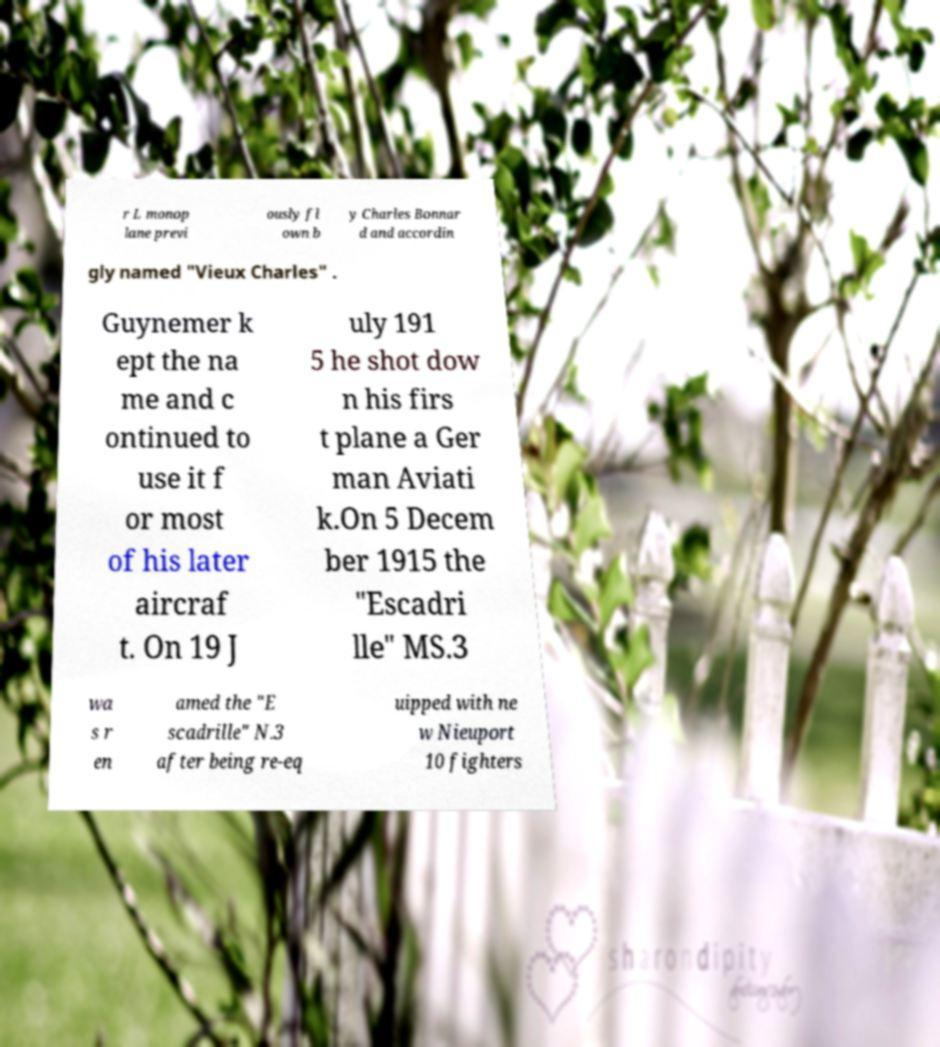Can you accurately transcribe the text from the provided image for me? r L monop lane previ ously fl own b y Charles Bonnar d and accordin gly named "Vieux Charles" . Guynemer k ept the na me and c ontinued to use it f or most of his later aircraf t. On 19 J uly 191 5 he shot dow n his firs t plane a Ger man Aviati k.On 5 Decem ber 1915 the "Escadri lle" MS.3 wa s r en amed the "E scadrille" N.3 after being re-eq uipped with ne w Nieuport 10 fighters 